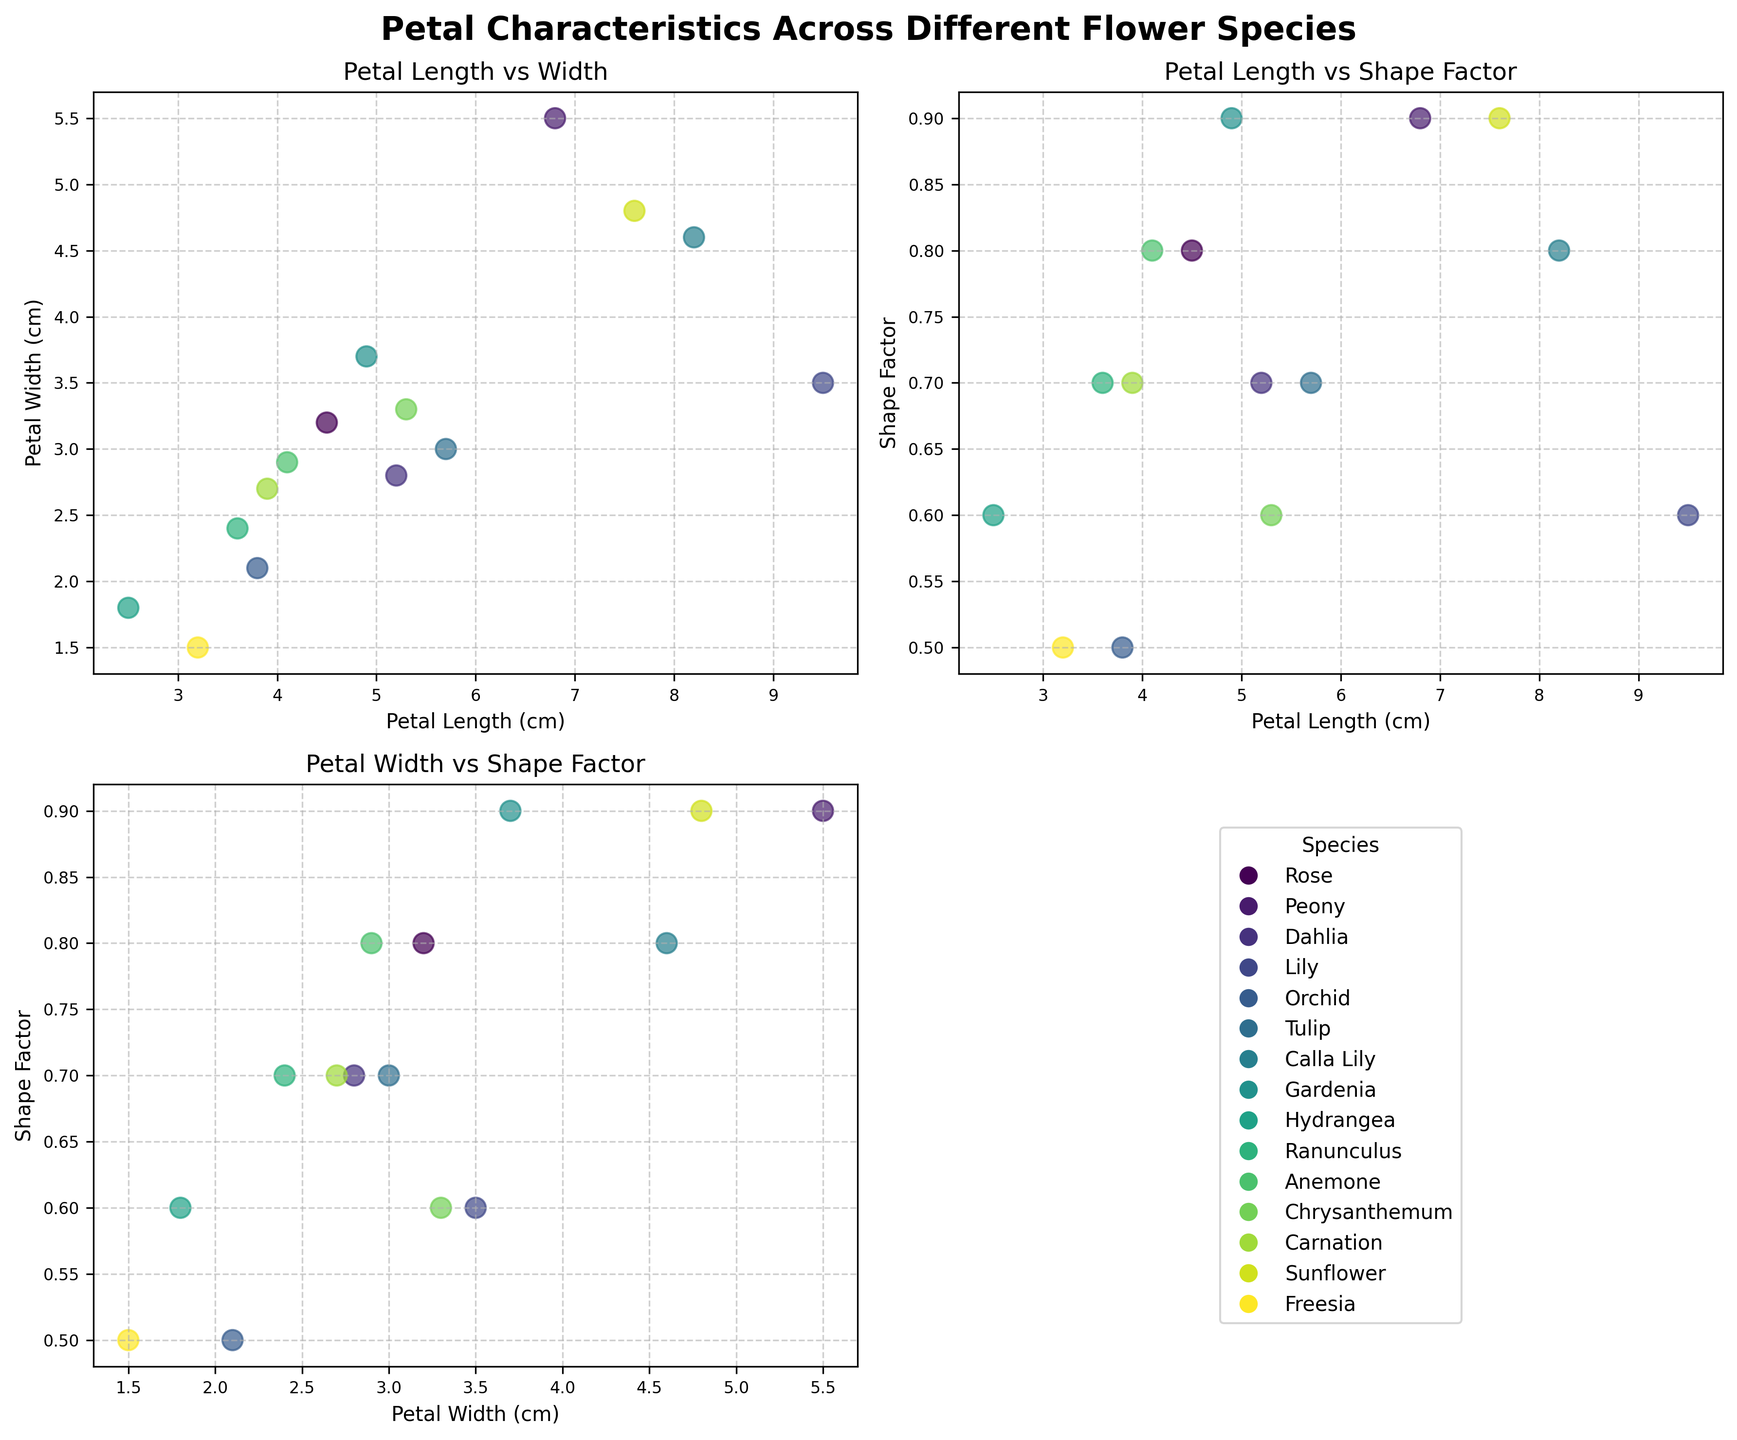What is the title of the subplot in the first row and first column? The title of the subplot in the first row and first column can be found directly above the scatter plot. Reading it from the figure, it is “Petal Length vs Width”.
Answer: Petal Length vs Width How many unique flower species are represented in the figure? The legend in the bottom-right subplot lists all the flower species using different colors for each. Counting the entries, there are 15 unique species.
Answer: 15 What is the maximum petal length observed, and which species does it belong to? The data point with the highest X-value in the scatter plots represents the maximum petal length. In the subplot "Petal Length vs Width", it reaches 9.5 cm, which corresponds to the Lily species.
Answer: 9.5 cm, Lily Which species have the highest shape factor and what is its value? In the "Petal Width vs Shape Factor" scatter plot, look for the highest Y-value point. The highest shape factor is observed for Peony, Gardenia, and Sunflower species, each with a shape factor of 0.9.
Answer: Peony, Gardenia, Sunflower, 0.9 What range of values does the petal width cover? In the "Petal Width vs Shape Factor" subplot, find the minimum and maximum values on the X-axis. The range of petal width values is from 1.5 cm to 5.5 cm.
Answer: 1.5 cm to 5.5 cm Is there any species with both a petal length above 8 cm and a shape factor above 0.8? In the "Petal Length vs Shape Factor" subplot, identify the data points with petal lengths above 8 cm and verify their corresponding shape factors. Both Calla Lily (8.2 cm, 0.8 shape factor) qualify.
Answer: Yes, Calla Lily Which subplot shows a positive correlation between the two variables? A positive correlation means that as one variable increases, the other also increases. In this case, "Petal Width vs Shape Factor" and "Petal Length vs Shape Factor" subplots do not show a clear positive trend, but "Petal Length vs Width" does.
Answer: Petal Length vs Width Which species has the smallest petal width and what is its shape factor? By identifying the smallest X-value in the "Petal Length vs Width" subplot and matching it with the corresponding shape factor, Freesia has the smallest petal width of 1.5 cm and a shape factor of 0.5.
Answer: Freesia, 0.5 Among the species with a petal width above 4 cm, which one has the shortest petal length? Checking the "Petal Length vs Width" subplot, identify species with a petal width above 4 cm and compare their petal lengths. Sunflower (7.6 cm) and Peony (6.8 cm) both exhibit petal lengths in the higher range, while Calla Lily (8.2 cm) and Hydrangea (2.5 cm) are respectively tallest and shortest.
Answer: None Calculate the average shape factor of all the flower species combined. Sum the shape factors of all the species and divide by the number of species. (0.8+0.9+0.7+0.6+0.5+0.7+0.8+0.9+0.6+0.7+0.8+0.6+0.7+0.9+0.5) / 15 = 10.7/15 ≈ 0.71
Answer: 0.71 